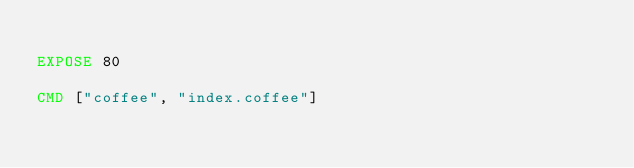<code> <loc_0><loc_0><loc_500><loc_500><_Dockerfile_>
EXPOSE 80

CMD ["coffee", "index.coffee"]
</code> 